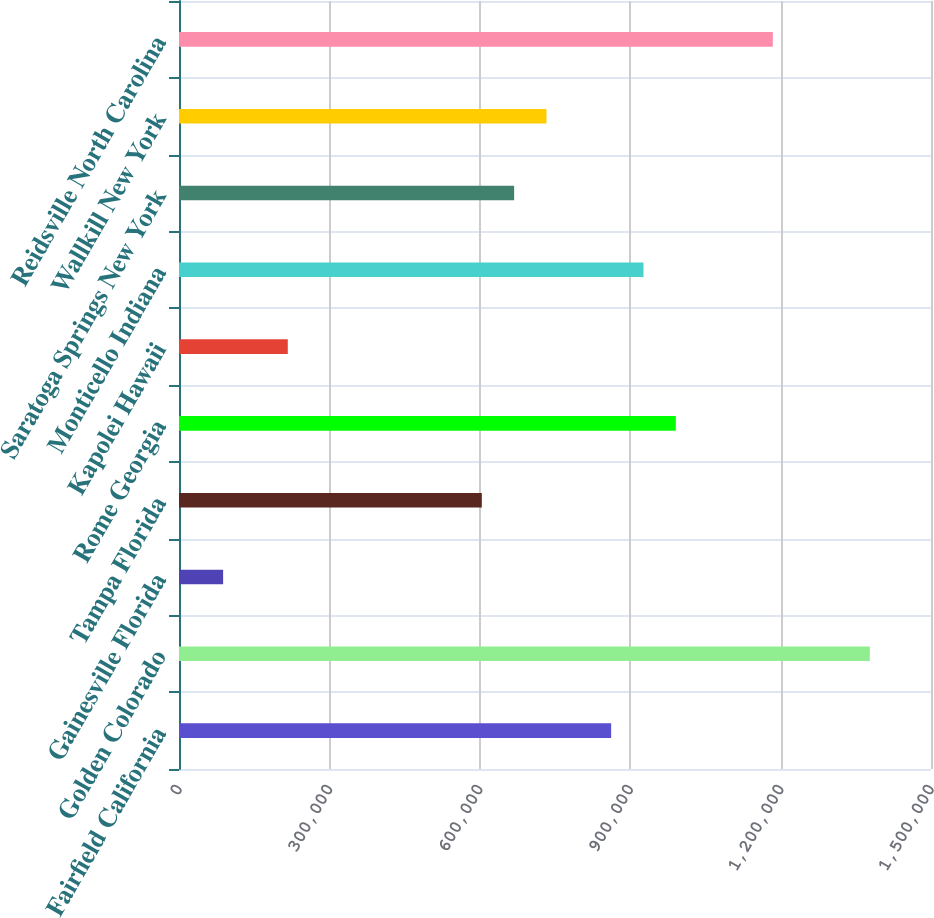Convert chart. <chart><loc_0><loc_0><loc_500><loc_500><bar_chart><fcel>Fairfield California<fcel>Golden Colorado<fcel>Gainesville Florida<fcel>Tampa Florida<fcel>Rome Georgia<fcel>Kapolei Hawaii<fcel>Monticello Indiana<fcel>Saratoga Springs New York<fcel>Wallkill New York<fcel>Reidsville North Carolina<nl><fcel>862000<fcel>1.378e+06<fcel>88000<fcel>604000<fcel>991000<fcel>217000<fcel>926500<fcel>668500<fcel>733000<fcel>1.1845e+06<nl></chart> 